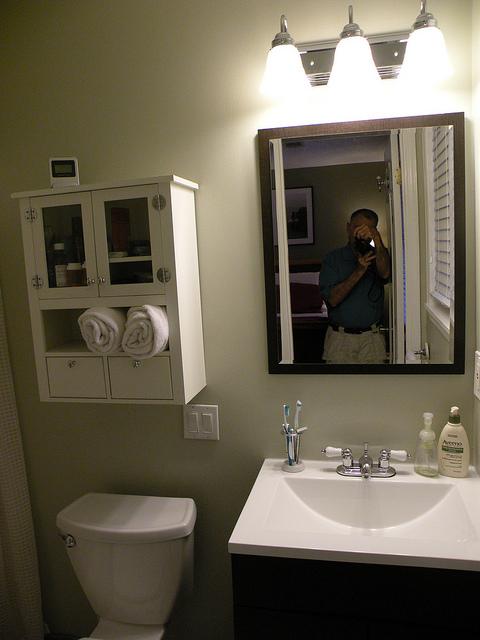What is on the man's face?
Keep it brief. Camera. What is on the wall above the light switches?
Keep it brief. Cabinet. Can you see the photographer in his picture?
Write a very short answer. Yes. How many light bulbs need to be replaced?
Keep it brief. 0. How many toothbrushes are on the counter?
Short answer required. 2. 